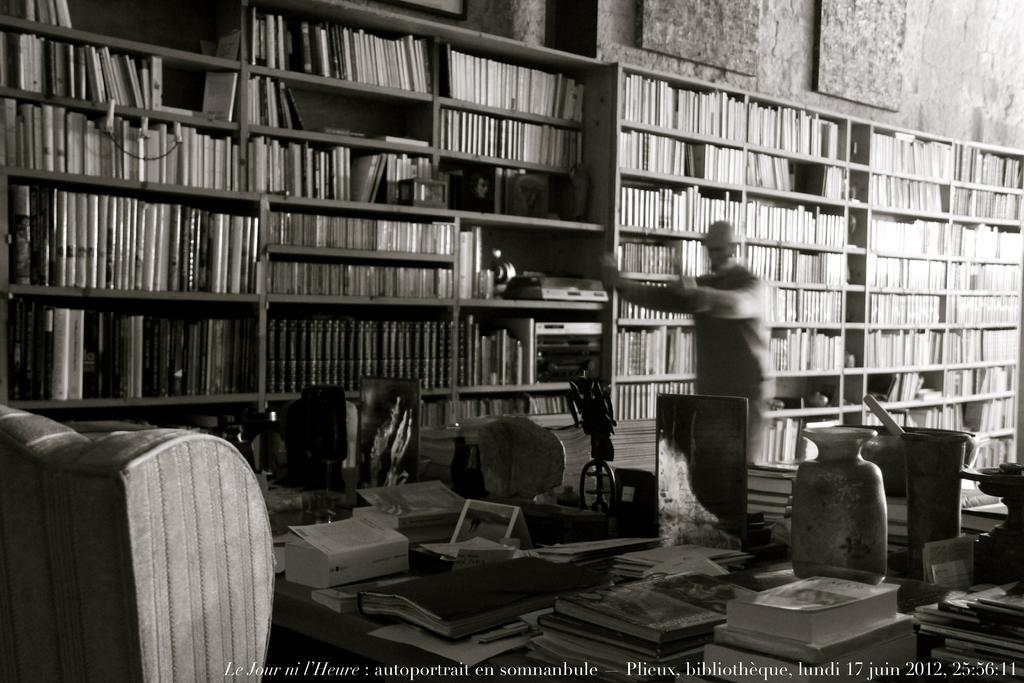What is present on the table in the image? There are many books on the table. What can be seen in the background of the image? There are multiple bookshelves in the image. What type of calendar is hanging on the wall in the image? There is no calendar present in the image; it only features books on the table and bookshelves in the background. 